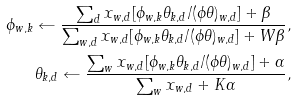Convert formula to latex. <formula><loc_0><loc_0><loc_500><loc_500>\phi _ { w , k } \leftarrow \frac { \sum _ { d } x _ { w , d } [ \phi _ { w , k } \theta _ { k , d } / ( \phi \theta ) _ { w , d } ] + \beta } { \sum _ { w , d } x _ { w , d } [ \phi _ { w , k } \theta _ { k , d } / ( \phi \theta ) _ { w , d } ] + W \beta } , \\ \theta _ { k , d } \leftarrow \frac { \sum _ { w } x _ { w , d } [ \phi _ { w , k } \theta _ { k , d } / ( \phi \theta ) _ { w , d } ] + \alpha } { \sum _ { w } x _ { w , d } + K \alpha } ,</formula> 